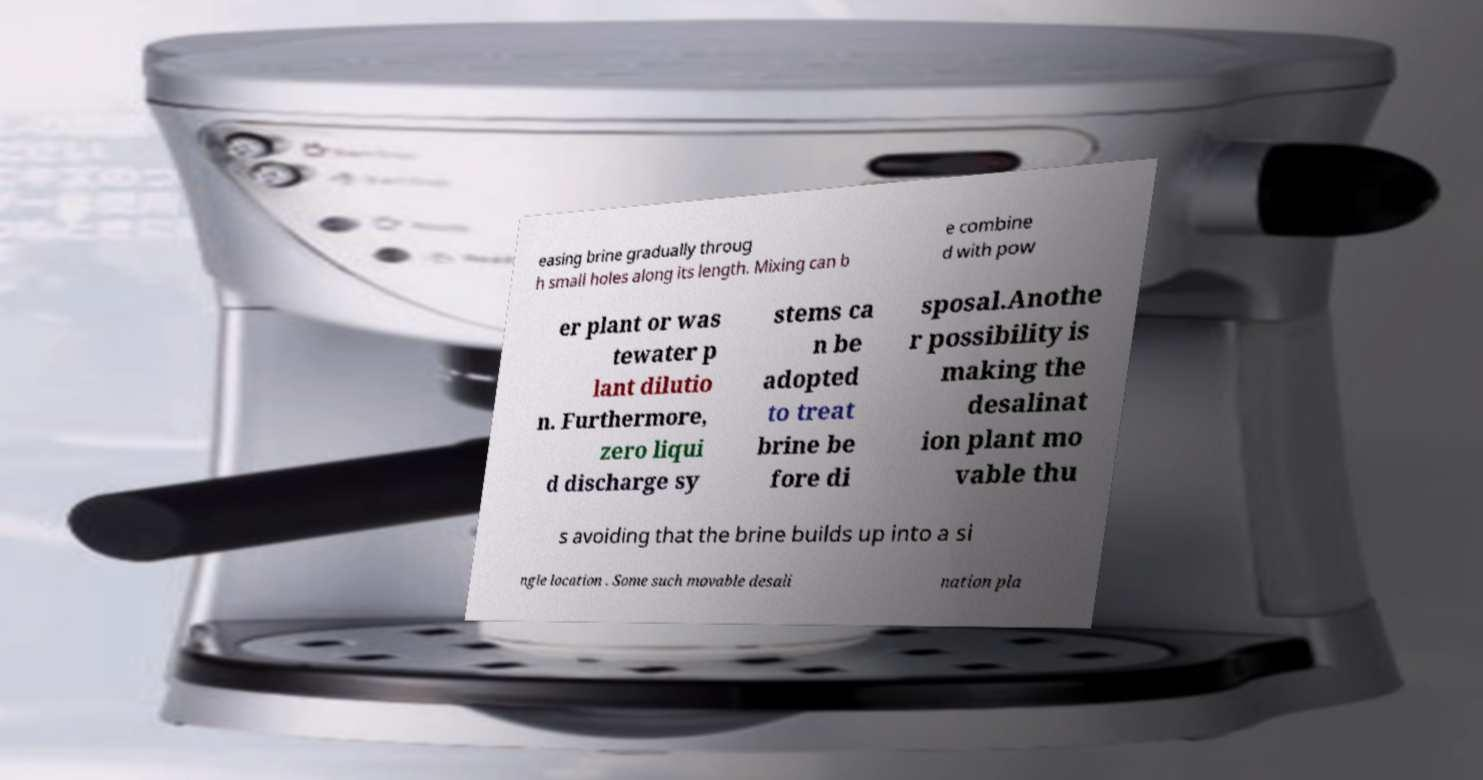Can you accurately transcribe the text from the provided image for me? easing brine gradually throug h small holes along its length. Mixing can b e combine d with pow er plant or was tewater p lant dilutio n. Furthermore, zero liqui d discharge sy stems ca n be adopted to treat brine be fore di sposal.Anothe r possibility is making the desalinat ion plant mo vable thu s avoiding that the brine builds up into a si ngle location . Some such movable desali nation pla 